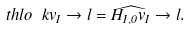Convert formula to latex. <formula><loc_0><loc_0><loc_500><loc_500>\ t h l o \ k v _ { I } \to l = \widehat { H _ { I , 0 } v _ { I } } \to l .</formula> 